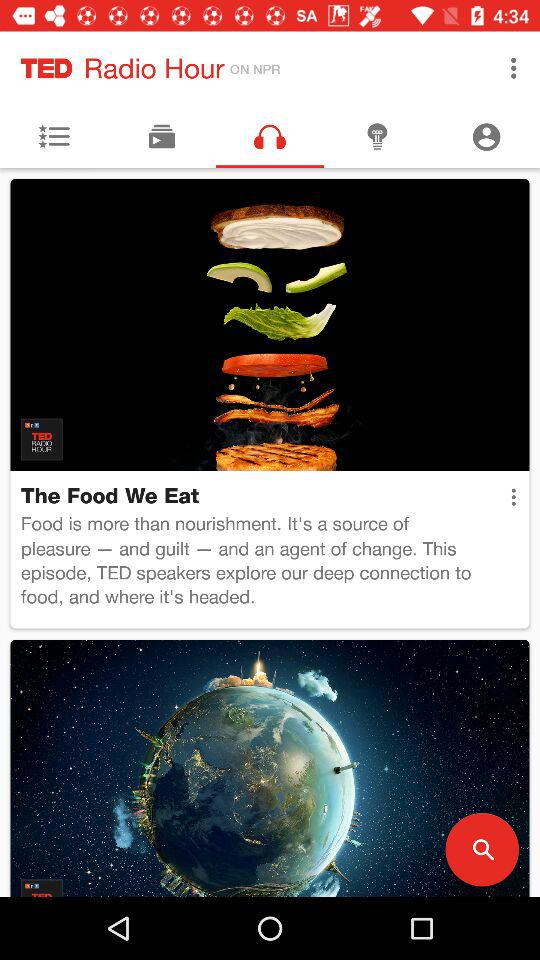What is the application name? The application name is "TED Radio Hour". 